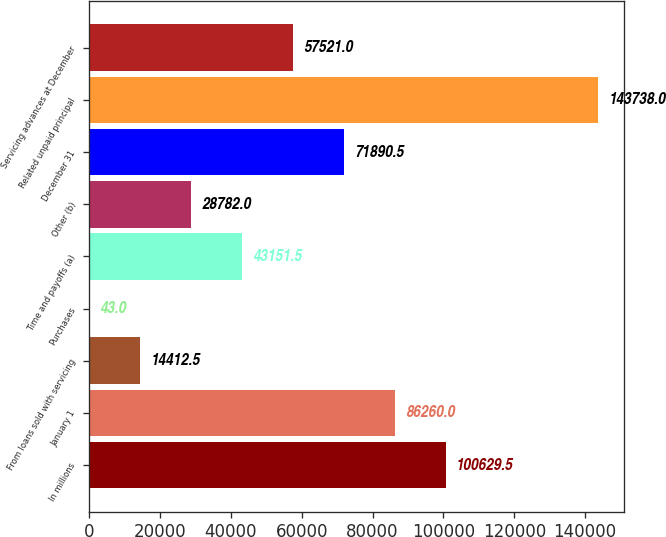<chart> <loc_0><loc_0><loc_500><loc_500><bar_chart><fcel>In millions<fcel>January 1<fcel>From loans sold with servicing<fcel>Purchases<fcel>Time and payoffs (a)<fcel>Other (b)<fcel>December 31<fcel>Related unpaid principal<fcel>Servicing advances at December<nl><fcel>100630<fcel>86260<fcel>14412.5<fcel>43<fcel>43151.5<fcel>28782<fcel>71890.5<fcel>143738<fcel>57521<nl></chart> 